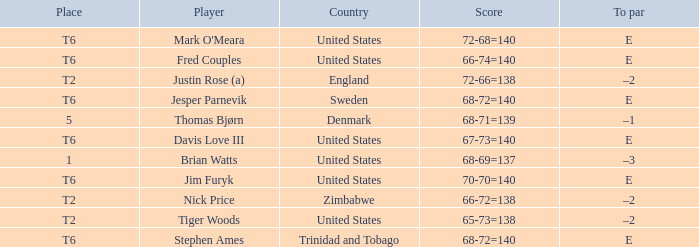In what place was Tiger Woods of the United States? T2. 